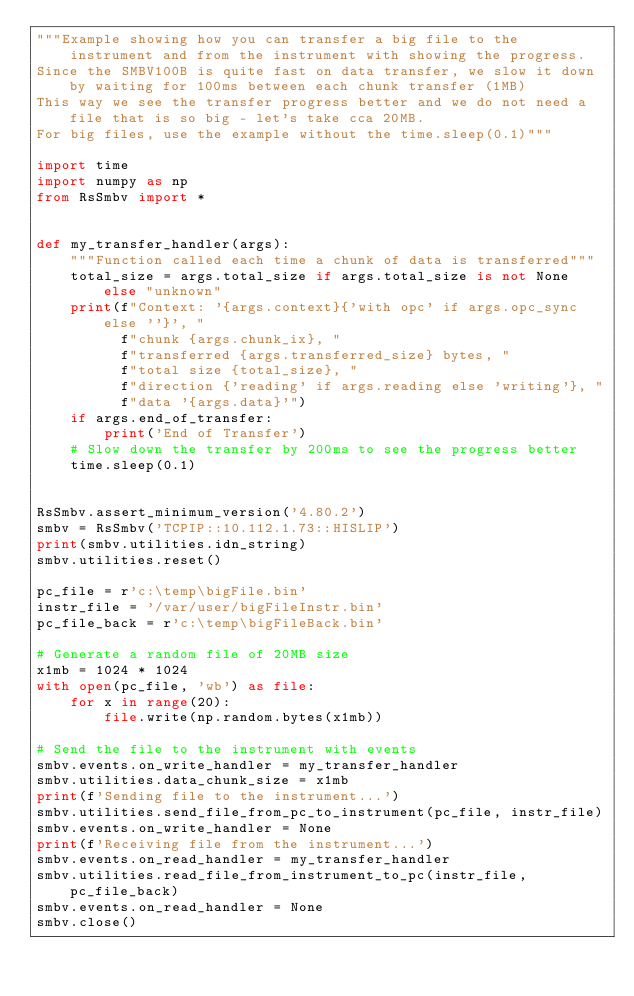Convert code to text. <code><loc_0><loc_0><loc_500><loc_500><_Python_>"""Example showing how you can transfer a big file to the instrument and from the instrument with showing the progress.
Since the SMBV100B is quite fast on data transfer, we slow it down by waiting for 100ms between each chunk transfer (1MB)
This way we see the transfer progress better and we do not need a file that is so big - let's take cca 20MB.
For big files, use the example without the time.sleep(0.1)"""

import time
import numpy as np
from RsSmbv import *


def my_transfer_handler(args):
    """Function called each time a chunk of data is transferred"""
    total_size = args.total_size if args.total_size is not None else "unknown"
    print(f"Context: '{args.context}{'with opc' if args.opc_sync else ''}', "
          f"chunk {args.chunk_ix}, "
          f"transferred {args.transferred_size} bytes, "
          f"total size {total_size}, "
          f"direction {'reading' if args.reading else 'writing'}, "
          f"data '{args.data}'")
    if args.end_of_transfer:
        print('End of Transfer')
    # Slow down the transfer by 200ms to see the progress better
    time.sleep(0.1)


RsSmbv.assert_minimum_version('4.80.2')
smbv = RsSmbv('TCPIP::10.112.1.73::HISLIP')
print(smbv.utilities.idn_string)
smbv.utilities.reset()

pc_file = r'c:\temp\bigFile.bin'
instr_file = '/var/user/bigFileInstr.bin'
pc_file_back = r'c:\temp\bigFileBack.bin'

# Generate a random file of 20MB size
x1mb = 1024 * 1024
with open(pc_file, 'wb') as file:
    for x in range(20):
        file.write(np.random.bytes(x1mb))

# Send the file to the instrument with events
smbv.events.on_write_handler = my_transfer_handler
smbv.utilities.data_chunk_size = x1mb
print(f'Sending file to the instrument...')
smbv.utilities.send_file_from_pc_to_instrument(pc_file, instr_file)
smbv.events.on_write_handler = None
print(f'Receiving file from the instrument...')
smbv.events.on_read_handler = my_transfer_handler
smbv.utilities.read_file_from_instrument_to_pc(instr_file, pc_file_back)
smbv.events.on_read_handler = None
smbv.close()
</code> 